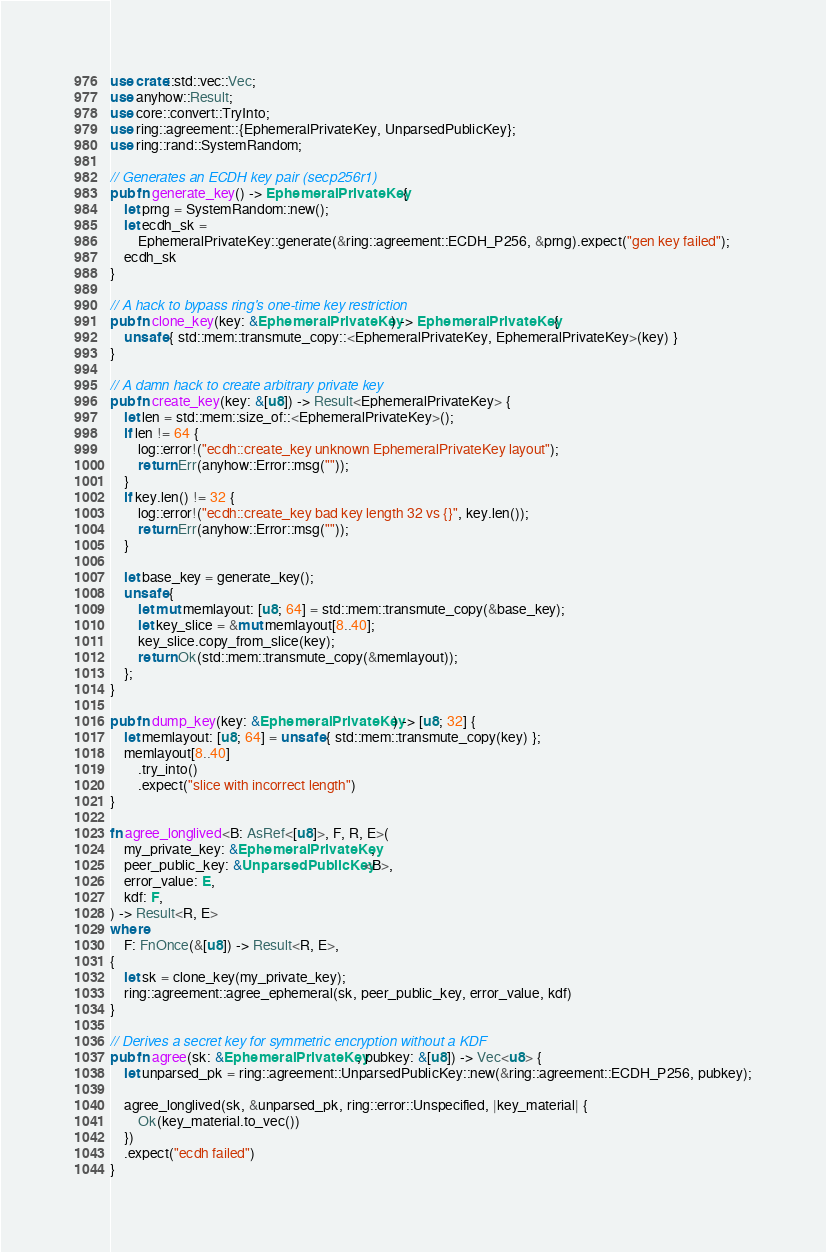Convert code to text. <code><loc_0><loc_0><loc_500><loc_500><_Rust_>use crate::std::vec::Vec;
use anyhow::Result;
use core::convert::TryInto;
use ring::agreement::{EphemeralPrivateKey, UnparsedPublicKey};
use ring::rand::SystemRandom;

// Generates an ECDH key pair (secp256r1)
pub fn generate_key() -> EphemeralPrivateKey {
    let prng = SystemRandom::new();
    let ecdh_sk =
        EphemeralPrivateKey::generate(&ring::agreement::ECDH_P256, &prng).expect("gen key failed");
    ecdh_sk
}

// A hack to bypass ring's one-time key restriction
pub fn clone_key(key: &EphemeralPrivateKey) -> EphemeralPrivateKey {
    unsafe { std::mem::transmute_copy::<EphemeralPrivateKey, EphemeralPrivateKey>(key) }
}

// A damn hack to create arbitrary private key
pub fn create_key(key: &[u8]) -> Result<EphemeralPrivateKey> {
    let len = std::mem::size_of::<EphemeralPrivateKey>();
    if len != 64 {
        log::error!("ecdh::create_key unknown EphemeralPrivateKey layout");
        return Err(anyhow::Error::msg(""));
    }
    if key.len() != 32 {
        log::error!("ecdh::create_key bad key length 32 vs {}", key.len());
        return Err(anyhow::Error::msg(""));
    }

    let base_key = generate_key();
    unsafe {
        let mut memlayout: [u8; 64] = std::mem::transmute_copy(&base_key);
        let key_slice = &mut memlayout[8..40];
        key_slice.copy_from_slice(key);
        return Ok(std::mem::transmute_copy(&memlayout));
    };
}

pub fn dump_key(key: &EphemeralPrivateKey) -> [u8; 32] {
    let memlayout: [u8; 64] = unsafe { std::mem::transmute_copy(key) };
    memlayout[8..40]
        .try_into()
        .expect("slice with incorrect length")
}

fn agree_longlived<B: AsRef<[u8]>, F, R, E>(
    my_private_key: &EphemeralPrivateKey,
    peer_public_key: &UnparsedPublicKey<B>,
    error_value: E,
    kdf: F,
) -> Result<R, E>
where
    F: FnOnce(&[u8]) -> Result<R, E>,
{
    let sk = clone_key(my_private_key);
    ring::agreement::agree_ephemeral(sk, peer_public_key, error_value, kdf)
}

// Derives a secret key for symmetric encryption without a KDF
pub fn agree(sk: &EphemeralPrivateKey, pubkey: &[u8]) -> Vec<u8> {
    let unparsed_pk = ring::agreement::UnparsedPublicKey::new(&ring::agreement::ECDH_P256, pubkey);

    agree_longlived(sk, &unparsed_pk, ring::error::Unspecified, |key_material| {
        Ok(key_material.to_vec())
    })
    .expect("ecdh failed")
}
</code> 